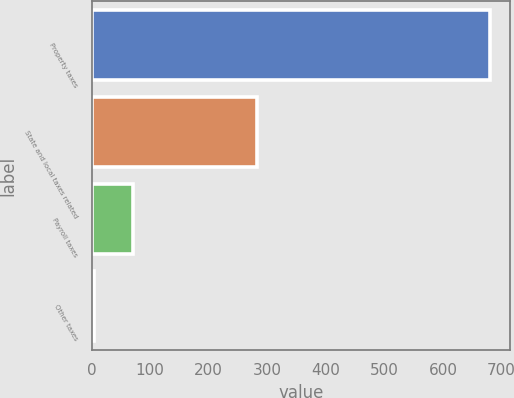Convert chart. <chart><loc_0><loc_0><loc_500><loc_500><bar_chart><fcel>Property taxes<fcel>State and local taxes related<fcel>Payroll taxes<fcel>Other taxes<nl><fcel>681<fcel>283<fcel>71.7<fcel>4<nl></chart> 